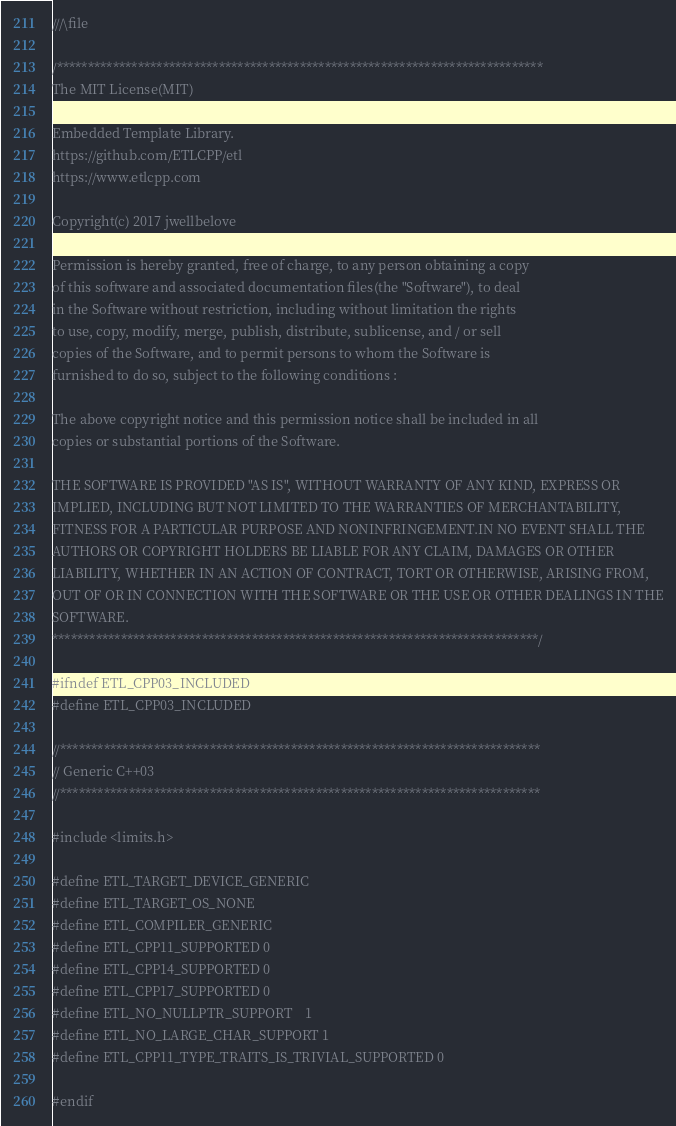Convert code to text. <code><loc_0><loc_0><loc_500><loc_500><_C_>///\file

/******************************************************************************
The MIT License(MIT)

Embedded Template Library.
https://github.com/ETLCPP/etl
https://www.etlcpp.com

Copyright(c) 2017 jwellbelove

Permission is hereby granted, free of charge, to any person obtaining a copy
of this software and associated documentation files(the "Software"), to deal
in the Software without restriction, including without limitation the rights
to use, copy, modify, merge, publish, distribute, sublicense, and / or sell
copies of the Software, and to permit persons to whom the Software is
furnished to do so, subject to the following conditions :

The above copyright notice and this permission notice shall be included in all
copies or substantial portions of the Software.

THE SOFTWARE IS PROVIDED "AS IS", WITHOUT WARRANTY OF ANY KIND, EXPRESS OR
IMPLIED, INCLUDING BUT NOT LIMITED TO THE WARRANTIES OF MERCHANTABILITY,
FITNESS FOR A PARTICULAR PURPOSE AND NONINFRINGEMENT.IN NO EVENT SHALL THE
AUTHORS OR COPYRIGHT HOLDERS BE LIABLE FOR ANY CLAIM, DAMAGES OR OTHER
LIABILITY, WHETHER IN AN ACTION OF CONTRACT, TORT OR OTHERWISE, ARISING FROM,
OUT OF OR IN CONNECTION WITH THE SOFTWARE OR THE USE OR OTHER DEALINGS IN THE
SOFTWARE.
******************************************************************************/

#ifndef ETL_CPP03_INCLUDED
#define ETL_CPP03_INCLUDED

//*****************************************************************************
// Generic C++03
//*****************************************************************************

#include <limits.h>

#define ETL_TARGET_DEVICE_GENERIC
#define ETL_TARGET_OS_NONE
#define ETL_COMPILER_GENERIC
#define ETL_CPP11_SUPPORTED 0
#define ETL_CPP14_SUPPORTED 0
#define ETL_CPP17_SUPPORTED 0
#define ETL_NO_NULLPTR_SUPPORT    1
#define ETL_NO_LARGE_CHAR_SUPPORT 1
#define ETL_CPP11_TYPE_TRAITS_IS_TRIVIAL_SUPPORTED 0

#endif
</code> 